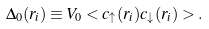<formula> <loc_0><loc_0><loc_500><loc_500>\Delta _ { 0 } ( r _ { i } ) \equiv V _ { 0 } < c _ { \uparrow } ( r _ { i } ) c _ { \downarrow } ( r _ { i } ) > .</formula> 